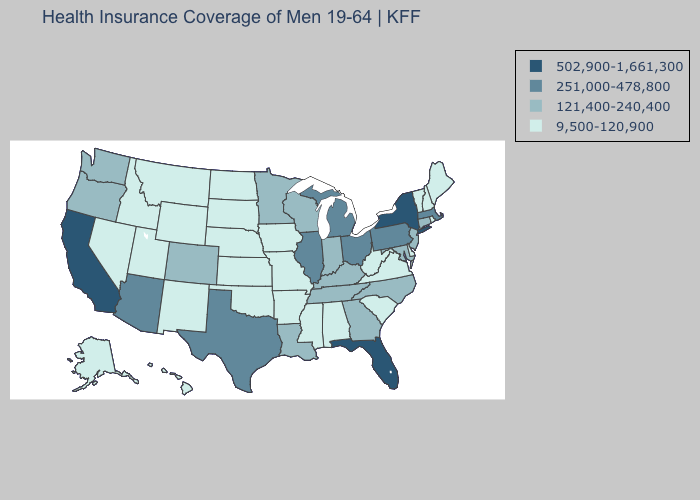Among the states that border California , does Nevada have the highest value?
Short answer required. No. Which states have the lowest value in the USA?
Concise answer only. Alabama, Alaska, Arkansas, Delaware, Hawaii, Idaho, Iowa, Kansas, Maine, Mississippi, Missouri, Montana, Nebraska, Nevada, New Hampshire, New Mexico, North Dakota, Oklahoma, Rhode Island, South Carolina, South Dakota, Utah, Vermont, Virginia, West Virginia, Wyoming. What is the highest value in the USA?
Give a very brief answer. 502,900-1,661,300. Among the states that border South Dakota , does Minnesota have the highest value?
Concise answer only. Yes. Name the states that have a value in the range 251,000-478,800?
Quick response, please. Arizona, Illinois, Massachusetts, Michigan, Ohio, Pennsylvania, Texas. How many symbols are there in the legend?
Be succinct. 4. Does Illinois have a lower value than California?
Be succinct. Yes. Name the states that have a value in the range 9,500-120,900?
Answer briefly. Alabama, Alaska, Arkansas, Delaware, Hawaii, Idaho, Iowa, Kansas, Maine, Mississippi, Missouri, Montana, Nebraska, Nevada, New Hampshire, New Mexico, North Dakota, Oklahoma, Rhode Island, South Carolina, South Dakota, Utah, Vermont, Virginia, West Virginia, Wyoming. Which states have the highest value in the USA?
Be succinct. California, Florida, New York. How many symbols are there in the legend?
Quick response, please. 4. What is the value of Oklahoma?
Write a very short answer. 9,500-120,900. Is the legend a continuous bar?
Write a very short answer. No. What is the value of Iowa?
Give a very brief answer. 9,500-120,900. What is the value of Arkansas?
Concise answer only. 9,500-120,900. 